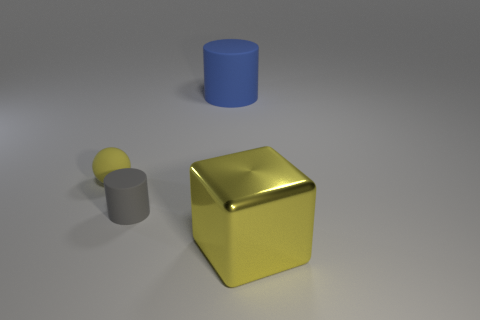Subtract all gray cylinders. How many cylinders are left? 1 Add 1 matte things. How many objects exist? 5 Subtract all cyan balls. Subtract all yellow blocks. How many balls are left? 1 Subtract all purple blocks. How many blue cylinders are left? 1 Subtract all cyan cubes. Subtract all yellow blocks. How many objects are left? 3 Add 1 blue cylinders. How many blue cylinders are left? 2 Add 3 blue matte spheres. How many blue matte spheres exist? 3 Subtract 0 blue cubes. How many objects are left? 4 Subtract 2 cylinders. How many cylinders are left? 0 